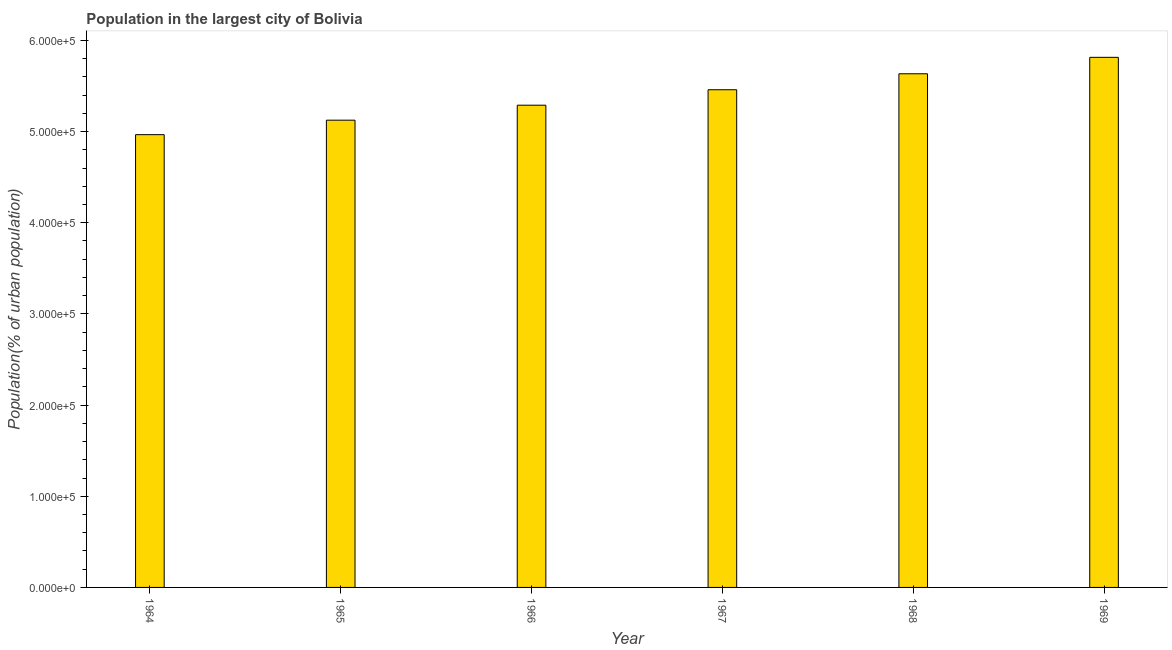Does the graph contain any zero values?
Make the answer very short. No. What is the title of the graph?
Offer a terse response. Population in the largest city of Bolivia. What is the label or title of the Y-axis?
Give a very brief answer. Population(% of urban population). What is the population in largest city in 1968?
Keep it short and to the point. 5.63e+05. Across all years, what is the maximum population in largest city?
Your response must be concise. 5.81e+05. Across all years, what is the minimum population in largest city?
Your response must be concise. 4.97e+05. In which year was the population in largest city maximum?
Your answer should be very brief. 1969. In which year was the population in largest city minimum?
Provide a succinct answer. 1964. What is the sum of the population in largest city?
Give a very brief answer. 3.23e+06. What is the difference between the population in largest city in 1964 and 1967?
Make the answer very short. -4.93e+04. What is the average population in largest city per year?
Your answer should be very brief. 5.38e+05. What is the median population in largest city?
Your answer should be very brief. 5.37e+05. Is the population in largest city in 1964 less than that in 1966?
Your response must be concise. Yes. What is the difference between the highest and the second highest population in largest city?
Make the answer very short. 1.80e+04. Is the sum of the population in largest city in 1965 and 1969 greater than the maximum population in largest city across all years?
Give a very brief answer. Yes. What is the difference between the highest and the lowest population in largest city?
Offer a very short reply. 8.48e+04. Are all the bars in the graph horizontal?
Your answer should be compact. No. What is the Population(% of urban population) in 1964?
Provide a succinct answer. 4.97e+05. What is the Population(% of urban population) of 1965?
Your response must be concise. 5.12e+05. What is the Population(% of urban population) of 1966?
Ensure brevity in your answer.  5.29e+05. What is the Population(% of urban population) of 1967?
Make the answer very short. 5.46e+05. What is the Population(% of urban population) of 1968?
Offer a terse response. 5.63e+05. What is the Population(% of urban population) in 1969?
Provide a short and direct response. 5.81e+05. What is the difference between the Population(% of urban population) in 1964 and 1965?
Offer a very short reply. -1.59e+04. What is the difference between the Population(% of urban population) in 1964 and 1966?
Your answer should be compact. -3.23e+04. What is the difference between the Population(% of urban population) in 1964 and 1967?
Offer a very short reply. -4.93e+04. What is the difference between the Population(% of urban population) in 1964 and 1968?
Your response must be concise. -6.68e+04. What is the difference between the Population(% of urban population) in 1964 and 1969?
Give a very brief answer. -8.48e+04. What is the difference between the Population(% of urban population) in 1965 and 1966?
Ensure brevity in your answer.  -1.64e+04. What is the difference between the Population(% of urban population) in 1965 and 1967?
Your response must be concise. -3.34e+04. What is the difference between the Population(% of urban population) in 1965 and 1968?
Make the answer very short. -5.09e+04. What is the difference between the Population(% of urban population) in 1965 and 1969?
Keep it short and to the point. -6.89e+04. What is the difference between the Population(% of urban population) in 1966 and 1967?
Your response must be concise. -1.70e+04. What is the difference between the Population(% of urban population) in 1966 and 1968?
Provide a short and direct response. -3.45e+04. What is the difference between the Population(% of urban population) in 1966 and 1969?
Your answer should be compact. -5.25e+04. What is the difference between the Population(% of urban population) in 1967 and 1968?
Keep it short and to the point. -1.75e+04. What is the difference between the Population(% of urban population) in 1967 and 1969?
Provide a succinct answer. -3.56e+04. What is the difference between the Population(% of urban population) in 1968 and 1969?
Your response must be concise. -1.80e+04. What is the ratio of the Population(% of urban population) in 1964 to that in 1966?
Ensure brevity in your answer.  0.94. What is the ratio of the Population(% of urban population) in 1964 to that in 1967?
Provide a succinct answer. 0.91. What is the ratio of the Population(% of urban population) in 1964 to that in 1968?
Your response must be concise. 0.88. What is the ratio of the Population(% of urban population) in 1964 to that in 1969?
Offer a very short reply. 0.85. What is the ratio of the Population(% of urban population) in 1965 to that in 1967?
Provide a succinct answer. 0.94. What is the ratio of the Population(% of urban population) in 1965 to that in 1968?
Provide a succinct answer. 0.91. What is the ratio of the Population(% of urban population) in 1965 to that in 1969?
Provide a succinct answer. 0.88. What is the ratio of the Population(% of urban population) in 1966 to that in 1967?
Offer a very short reply. 0.97. What is the ratio of the Population(% of urban population) in 1966 to that in 1968?
Give a very brief answer. 0.94. What is the ratio of the Population(% of urban population) in 1966 to that in 1969?
Your answer should be compact. 0.91. What is the ratio of the Population(% of urban population) in 1967 to that in 1969?
Provide a short and direct response. 0.94. What is the ratio of the Population(% of urban population) in 1968 to that in 1969?
Offer a very short reply. 0.97. 